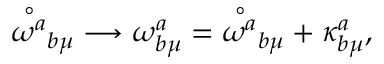Convert formula to latex. <formula><loc_0><loc_0><loc_500><loc_500>{ \stackrel { \circ } { \omega ^ { a } } } _ { b \mu } \longrightarrow \omega _ { b \mu } ^ { a } = { \stackrel { \circ } { \omega ^ { a } } } _ { b \mu } + \kappa _ { b \mu } ^ { a } ,</formula> 